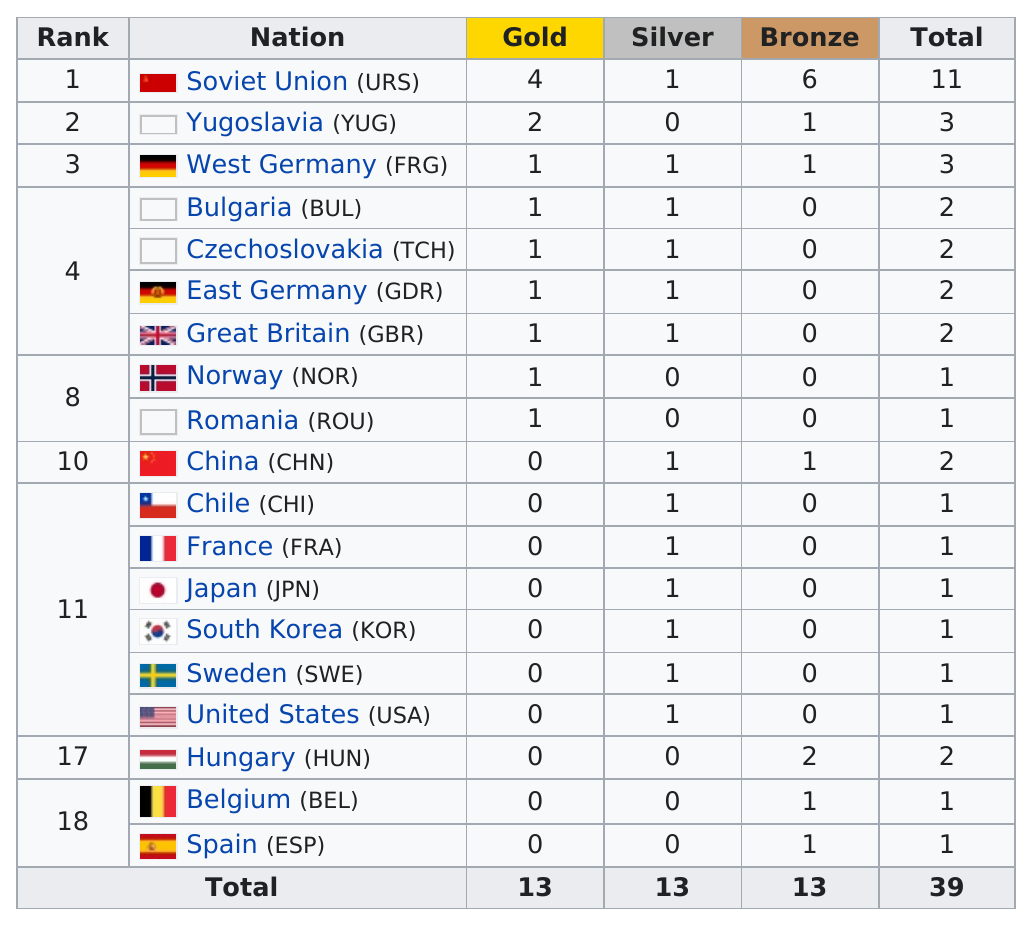Identify some key points in this picture. After Yugoslavia, West Germany (FRG) was ranked as the next country in the FIFA World Rankings. The Soviet Union (URS) earned the most gold medals in a country. The Soviet Union won the most medals in shooting at the 1988 Summer Olympics. Chile (CHI) was ranked in the top 11 countries. The countries that did not have any gold medal winners at the 2020 Summer Olympics are China (CHN), Chile (CHI), France (FRA), Japan (JPN), South Korea (KOR), Sweden (SWE), United States (USA), Hungary (HUN), Belgium (BEL), and Spain (ESP). 